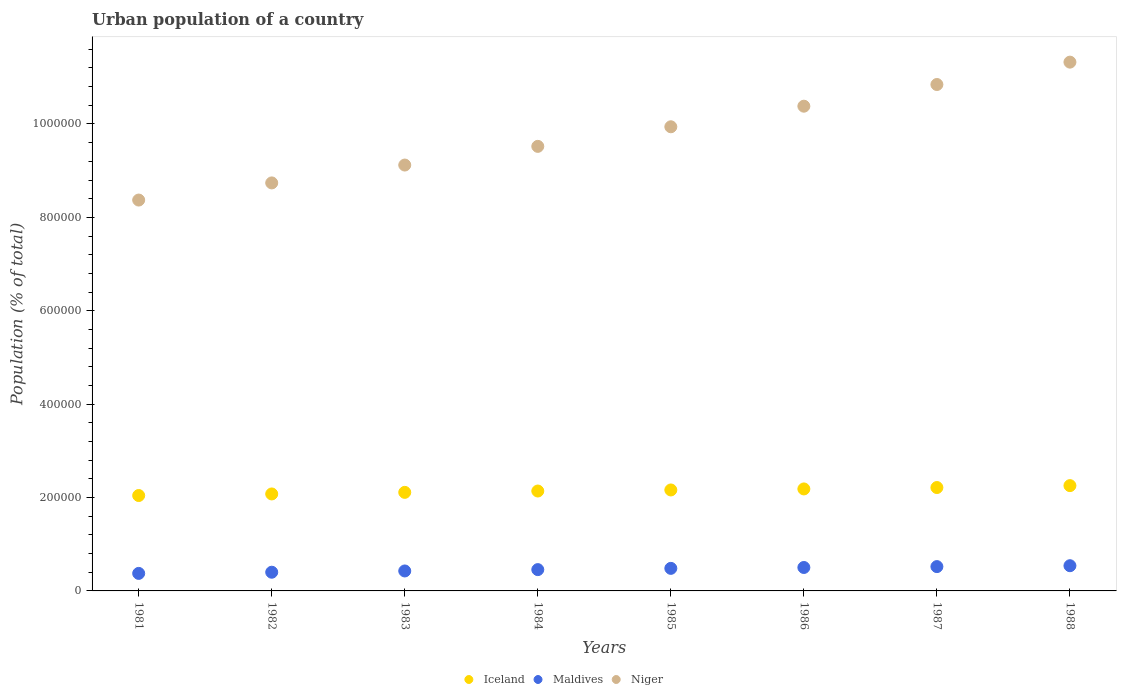Is the number of dotlines equal to the number of legend labels?
Provide a short and direct response. Yes. What is the urban population in Maldives in 1985?
Make the answer very short. 4.83e+04. Across all years, what is the maximum urban population in Niger?
Your response must be concise. 1.13e+06. Across all years, what is the minimum urban population in Niger?
Your answer should be compact. 8.37e+05. In which year was the urban population in Niger minimum?
Offer a terse response. 1981. What is the total urban population in Iceland in the graph?
Provide a short and direct response. 1.72e+06. What is the difference between the urban population in Maldives in 1981 and that in 1987?
Offer a terse response. -1.46e+04. What is the difference between the urban population in Niger in 1987 and the urban population in Maldives in 1982?
Offer a terse response. 1.04e+06. What is the average urban population in Niger per year?
Give a very brief answer. 9.78e+05. In the year 1982, what is the difference between the urban population in Iceland and urban population in Maldives?
Your answer should be compact. 1.68e+05. What is the ratio of the urban population in Maldives in 1982 to that in 1987?
Provide a succinct answer. 0.77. Is the urban population in Niger in 1981 less than that in 1982?
Provide a short and direct response. Yes. What is the difference between the highest and the second highest urban population in Niger?
Your response must be concise. 4.79e+04. What is the difference between the highest and the lowest urban population in Niger?
Provide a short and direct response. 2.95e+05. Is it the case that in every year, the sum of the urban population in Maldives and urban population in Iceland  is greater than the urban population in Niger?
Your answer should be compact. No. How many dotlines are there?
Make the answer very short. 3. Are the values on the major ticks of Y-axis written in scientific E-notation?
Your answer should be compact. No. Where does the legend appear in the graph?
Provide a short and direct response. Bottom center. How many legend labels are there?
Provide a succinct answer. 3. What is the title of the graph?
Ensure brevity in your answer.  Urban population of a country. Does "Mozambique" appear as one of the legend labels in the graph?
Ensure brevity in your answer.  No. What is the label or title of the X-axis?
Offer a very short reply. Years. What is the label or title of the Y-axis?
Make the answer very short. Population (% of total). What is the Population (% of total) of Iceland in 1981?
Offer a very short reply. 2.04e+05. What is the Population (% of total) of Maldives in 1981?
Give a very brief answer. 3.75e+04. What is the Population (% of total) of Niger in 1981?
Your response must be concise. 8.37e+05. What is the Population (% of total) in Iceland in 1982?
Provide a short and direct response. 2.08e+05. What is the Population (% of total) of Maldives in 1982?
Offer a terse response. 4.00e+04. What is the Population (% of total) in Niger in 1982?
Provide a succinct answer. 8.74e+05. What is the Population (% of total) of Iceland in 1983?
Keep it short and to the point. 2.11e+05. What is the Population (% of total) of Maldives in 1983?
Provide a short and direct response. 4.28e+04. What is the Population (% of total) in Niger in 1983?
Your answer should be compact. 9.12e+05. What is the Population (% of total) in Iceland in 1984?
Give a very brief answer. 2.14e+05. What is the Population (% of total) in Maldives in 1984?
Your response must be concise. 4.56e+04. What is the Population (% of total) in Niger in 1984?
Make the answer very short. 9.52e+05. What is the Population (% of total) in Iceland in 1985?
Your response must be concise. 2.16e+05. What is the Population (% of total) in Maldives in 1985?
Provide a succinct answer. 4.83e+04. What is the Population (% of total) of Niger in 1985?
Provide a short and direct response. 9.94e+05. What is the Population (% of total) in Iceland in 1986?
Give a very brief answer. 2.18e+05. What is the Population (% of total) in Maldives in 1986?
Give a very brief answer. 5.02e+04. What is the Population (% of total) in Niger in 1986?
Provide a succinct answer. 1.04e+06. What is the Population (% of total) in Iceland in 1987?
Your response must be concise. 2.21e+05. What is the Population (% of total) of Maldives in 1987?
Your answer should be compact. 5.21e+04. What is the Population (% of total) in Niger in 1987?
Provide a short and direct response. 1.08e+06. What is the Population (% of total) of Iceland in 1988?
Keep it short and to the point. 2.26e+05. What is the Population (% of total) in Maldives in 1988?
Provide a short and direct response. 5.40e+04. What is the Population (% of total) of Niger in 1988?
Provide a short and direct response. 1.13e+06. Across all years, what is the maximum Population (% of total) of Iceland?
Ensure brevity in your answer.  2.26e+05. Across all years, what is the maximum Population (% of total) in Maldives?
Provide a succinct answer. 5.40e+04. Across all years, what is the maximum Population (% of total) of Niger?
Provide a short and direct response. 1.13e+06. Across all years, what is the minimum Population (% of total) of Iceland?
Provide a succinct answer. 2.04e+05. Across all years, what is the minimum Population (% of total) in Maldives?
Provide a short and direct response. 3.75e+04. Across all years, what is the minimum Population (% of total) of Niger?
Your answer should be very brief. 8.37e+05. What is the total Population (% of total) of Iceland in the graph?
Keep it short and to the point. 1.72e+06. What is the total Population (% of total) in Maldives in the graph?
Provide a succinct answer. 3.71e+05. What is the total Population (% of total) in Niger in the graph?
Make the answer very short. 7.82e+06. What is the difference between the Population (% of total) in Iceland in 1981 and that in 1982?
Your response must be concise. -3374. What is the difference between the Population (% of total) in Maldives in 1981 and that in 1982?
Your answer should be very brief. -2517. What is the difference between the Population (% of total) in Niger in 1981 and that in 1982?
Your answer should be compact. -3.67e+04. What is the difference between the Population (% of total) in Iceland in 1981 and that in 1983?
Keep it short and to the point. -6762. What is the difference between the Population (% of total) of Maldives in 1981 and that in 1983?
Give a very brief answer. -5229. What is the difference between the Population (% of total) in Niger in 1981 and that in 1983?
Keep it short and to the point. -7.50e+04. What is the difference between the Population (% of total) of Iceland in 1981 and that in 1984?
Provide a succinct answer. -9635. What is the difference between the Population (% of total) in Maldives in 1981 and that in 1984?
Provide a succinct answer. -8106. What is the difference between the Population (% of total) of Niger in 1981 and that in 1984?
Your answer should be very brief. -1.15e+05. What is the difference between the Population (% of total) in Iceland in 1981 and that in 1985?
Your answer should be very brief. -1.19e+04. What is the difference between the Population (% of total) in Maldives in 1981 and that in 1985?
Offer a terse response. -1.08e+04. What is the difference between the Population (% of total) of Niger in 1981 and that in 1985?
Provide a succinct answer. -1.57e+05. What is the difference between the Population (% of total) of Iceland in 1981 and that in 1986?
Give a very brief answer. -1.41e+04. What is the difference between the Population (% of total) in Maldives in 1981 and that in 1986?
Your answer should be very brief. -1.27e+04. What is the difference between the Population (% of total) in Niger in 1981 and that in 1986?
Provide a succinct answer. -2.01e+05. What is the difference between the Population (% of total) in Iceland in 1981 and that in 1987?
Ensure brevity in your answer.  -1.71e+04. What is the difference between the Population (% of total) of Maldives in 1981 and that in 1987?
Your answer should be very brief. -1.46e+04. What is the difference between the Population (% of total) of Niger in 1981 and that in 1987?
Give a very brief answer. -2.47e+05. What is the difference between the Population (% of total) in Iceland in 1981 and that in 1988?
Make the answer very short. -2.12e+04. What is the difference between the Population (% of total) in Maldives in 1981 and that in 1988?
Provide a short and direct response. -1.65e+04. What is the difference between the Population (% of total) in Niger in 1981 and that in 1988?
Provide a succinct answer. -2.95e+05. What is the difference between the Population (% of total) of Iceland in 1982 and that in 1983?
Your answer should be compact. -3388. What is the difference between the Population (% of total) in Maldives in 1982 and that in 1983?
Keep it short and to the point. -2712. What is the difference between the Population (% of total) in Niger in 1982 and that in 1983?
Offer a very short reply. -3.83e+04. What is the difference between the Population (% of total) in Iceland in 1982 and that in 1984?
Provide a succinct answer. -6261. What is the difference between the Population (% of total) of Maldives in 1982 and that in 1984?
Provide a succinct answer. -5589. What is the difference between the Population (% of total) in Niger in 1982 and that in 1984?
Your answer should be very brief. -7.83e+04. What is the difference between the Population (% of total) of Iceland in 1982 and that in 1985?
Provide a short and direct response. -8558. What is the difference between the Population (% of total) in Maldives in 1982 and that in 1985?
Make the answer very short. -8275. What is the difference between the Population (% of total) in Niger in 1982 and that in 1985?
Your answer should be very brief. -1.20e+05. What is the difference between the Population (% of total) of Iceland in 1982 and that in 1986?
Give a very brief answer. -1.07e+04. What is the difference between the Population (% of total) in Maldives in 1982 and that in 1986?
Your answer should be compact. -1.01e+04. What is the difference between the Population (% of total) of Niger in 1982 and that in 1986?
Provide a short and direct response. -1.64e+05. What is the difference between the Population (% of total) in Iceland in 1982 and that in 1987?
Keep it short and to the point. -1.37e+04. What is the difference between the Population (% of total) of Maldives in 1982 and that in 1987?
Ensure brevity in your answer.  -1.20e+04. What is the difference between the Population (% of total) of Niger in 1982 and that in 1987?
Offer a very short reply. -2.11e+05. What is the difference between the Population (% of total) in Iceland in 1982 and that in 1988?
Your answer should be very brief. -1.78e+04. What is the difference between the Population (% of total) of Maldives in 1982 and that in 1988?
Your response must be concise. -1.39e+04. What is the difference between the Population (% of total) in Niger in 1982 and that in 1988?
Your answer should be compact. -2.59e+05. What is the difference between the Population (% of total) of Iceland in 1983 and that in 1984?
Your response must be concise. -2873. What is the difference between the Population (% of total) in Maldives in 1983 and that in 1984?
Your answer should be compact. -2877. What is the difference between the Population (% of total) of Niger in 1983 and that in 1984?
Offer a very short reply. -4.00e+04. What is the difference between the Population (% of total) of Iceland in 1983 and that in 1985?
Give a very brief answer. -5170. What is the difference between the Population (% of total) in Maldives in 1983 and that in 1985?
Keep it short and to the point. -5563. What is the difference between the Population (% of total) in Niger in 1983 and that in 1985?
Your answer should be compact. -8.20e+04. What is the difference between the Population (% of total) of Iceland in 1983 and that in 1986?
Provide a short and direct response. -7359. What is the difference between the Population (% of total) in Maldives in 1983 and that in 1986?
Your answer should be very brief. -7435. What is the difference between the Population (% of total) in Niger in 1983 and that in 1986?
Your response must be concise. -1.26e+05. What is the difference between the Population (% of total) of Iceland in 1983 and that in 1987?
Offer a very short reply. -1.04e+04. What is the difference between the Population (% of total) of Maldives in 1983 and that in 1987?
Provide a short and direct response. -9326. What is the difference between the Population (% of total) in Niger in 1983 and that in 1987?
Offer a terse response. -1.72e+05. What is the difference between the Population (% of total) of Iceland in 1983 and that in 1988?
Keep it short and to the point. -1.44e+04. What is the difference between the Population (% of total) of Maldives in 1983 and that in 1988?
Provide a short and direct response. -1.12e+04. What is the difference between the Population (% of total) in Niger in 1983 and that in 1988?
Your answer should be compact. -2.20e+05. What is the difference between the Population (% of total) of Iceland in 1984 and that in 1985?
Ensure brevity in your answer.  -2297. What is the difference between the Population (% of total) in Maldives in 1984 and that in 1985?
Keep it short and to the point. -2686. What is the difference between the Population (% of total) in Niger in 1984 and that in 1985?
Make the answer very short. -4.19e+04. What is the difference between the Population (% of total) in Iceland in 1984 and that in 1986?
Give a very brief answer. -4486. What is the difference between the Population (% of total) in Maldives in 1984 and that in 1986?
Provide a short and direct response. -4558. What is the difference between the Population (% of total) of Niger in 1984 and that in 1986?
Keep it short and to the point. -8.60e+04. What is the difference between the Population (% of total) of Iceland in 1984 and that in 1987?
Give a very brief answer. -7484. What is the difference between the Population (% of total) of Maldives in 1984 and that in 1987?
Your response must be concise. -6449. What is the difference between the Population (% of total) in Niger in 1984 and that in 1987?
Your answer should be very brief. -1.32e+05. What is the difference between the Population (% of total) of Iceland in 1984 and that in 1988?
Your answer should be very brief. -1.16e+04. What is the difference between the Population (% of total) in Maldives in 1984 and that in 1988?
Your answer should be very brief. -8351. What is the difference between the Population (% of total) in Niger in 1984 and that in 1988?
Offer a very short reply. -1.80e+05. What is the difference between the Population (% of total) of Iceland in 1985 and that in 1986?
Keep it short and to the point. -2189. What is the difference between the Population (% of total) in Maldives in 1985 and that in 1986?
Your answer should be very brief. -1872. What is the difference between the Population (% of total) of Niger in 1985 and that in 1986?
Your response must be concise. -4.41e+04. What is the difference between the Population (% of total) in Iceland in 1985 and that in 1987?
Offer a very short reply. -5187. What is the difference between the Population (% of total) in Maldives in 1985 and that in 1987?
Your answer should be very brief. -3763. What is the difference between the Population (% of total) of Niger in 1985 and that in 1987?
Make the answer very short. -9.05e+04. What is the difference between the Population (% of total) in Iceland in 1985 and that in 1988?
Give a very brief answer. -9274. What is the difference between the Population (% of total) of Maldives in 1985 and that in 1988?
Offer a very short reply. -5665. What is the difference between the Population (% of total) in Niger in 1985 and that in 1988?
Ensure brevity in your answer.  -1.38e+05. What is the difference between the Population (% of total) of Iceland in 1986 and that in 1987?
Your answer should be compact. -2998. What is the difference between the Population (% of total) in Maldives in 1986 and that in 1987?
Your answer should be compact. -1891. What is the difference between the Population (% of total) of Niger in 1986 and that in 1987?
Keep it short and to the point. -4.64e+04. What is the difference between the Population (% of total) of Iceland in 1986 and that in 1988?
Offer a terse response. -7085. What is the difference between the Population (% of total) of Maldives in 1986 and that in 1988?
Your response must be concise. -3793. What is the difference between the Population (% of total) of Niger in 1986 and that in 1988?
Keep it short and to the point. -9.43e+04. What is the difference between the Population (% of total) of Iceland in 1987 and that in 1988?
Keep it short and to the point. -4087. What is the difference between the Population (% of total) in Maldives in 1987 and that in 1988?
Ensure brevity in your answer.  -1902. What is the difference between the Population (% of total) in Niger in 1987 and that in 1988?
Provide a short and direct response. -4.79e+04. What is the difference between the Population (% of total) in Iceland in 1981 and the Population (% of total) in Maldives in 1982?
Offer a very short reply. 1.64e+05. What is the difference between the Population (% of total) of Iceland in 1981 and the Population (% of total) of Niger in 1982?
Ensure brevity in your answer.  -6.69e+05. What is the difference between the Population (% of total) in Maldives in 1981 and the Population (% of total) in Niger in 1982?
Offer a very short reply. -8.36e+05. What is the difference between the Population (% of total) in Iceland in 1981 and the Population (% of total) in Maldives in 1983?
Provide a succinct answer. 1.62e+05. What is the difference between the Population (% of total) of Iceland in 1981 and the Population (% of total) of Niger in 1983?
Make the answer very short. -7.08e+05. What is the difference between the Population (% of total) in Maldives in 1981 and the Population (% of total) in Niger in 1983?
Your answer should be compact. -8.75e+05. What is the difference between the Population (% of total) in Iceland in 1981 and the Population (% of total) in Maldives in 1984?
Keep it short and to the point. 1.59e+05. What is the difference between the Population (% of total) in Iceland in 1981 and the Population (% of total) in Niger in 1984?
Your answer should be very brief. -7.48e+05. What is the difference between the Population (% of total) in Maldives in 1981 and the Population (% of total) in Niger in 1984?
Offer a terse response. -9.15e+05. What is the difference between the Population (% of total) in Iceland in 1981 and the Population (% of total) in Maldives in 1985?
Keep it short and to the point. 1.56e+05. What is the difference between the Population (% of total) of Iceland in 1981 and the Population (% of total) of Niger in 1985?
Ensure brevity in your answer.  -7.90e+05. What is the difference between the Population (% of total) of Maldives in 1981 and the Population (% of total) of Niger in 1985?
Offer a terse response. -9.56e+05. What is the difference between the Population (% of total) of Iceland in 1981 and the Population (% of total) of Maldives in 1986?
Provide a short and direct response. 1.54e+05. What is the difference between the Population (% of total) of Iceland in 1981 and the Population (% of total) of Niger in 1986?
Offer a terse response. -8.34e+05. What is the difference between the Population (% of total) in Maldives in 1981 and the Population (% of total) in Niger in 1986?
Make the answer very short. -1.00e+06. What is the difference between the Population (% of total) in Iceland in 1981 and the Population (% of total) in Maldives in 1987?
Your answer should be very brief. 1.52e+05. What is the difference between the Population (% of total) of Iceland in 1981 and the Population (% of total) of Niger in 1987?
Your answer should be compact. -8.80e+05. What is the difference between the Population (% of total) of Maldives in 1981 and the Population (% of total) of Niger in 1987?
Give a very brief answer. -1.05e+06. What is the difference between the Population (% of total) in Iceland in 1981 and the Population (% of total) in Maldives in 1988?
Your answer should be compact. 1.50e+05. What is the difference between the Population (% of total) of Iceland in 1981 and the Population (% of total) of Niger in 1988?
Keep it short and to the point. -9.28e+05. What is the difference between the Population (% of total) in Maldives in 1981 and the Population (% of total) in Niger in 1988?
Ensure brevity in your answer.  -1.09e+06. What is the difference between the Population (% of total) of Iceland in 1982 and the Population (% of total) of Maldives in 1983?
Your answer should be compact. 1.65e+05. What is the difference between the Population (% of total) of Iceland in 1982 and the Population (% of total) of Niger in 1983?
Ensure brevity in your answer.  -7.04e+05. What is the difference between the Population (% of total) in Maldives in 1982 and the Population (% of total) in Niger in 1983?
Keep it short and to the point. -8.72e+05. What is the difference between the Population (% of total) in Iceland in 1982 and the Population (% of total) in Maldives in 1984?
Provide a short and direct response. 1.62e+05. What is the difference between the Population (% of total) of Iceland in 1982 and the Population (% of total) of Niger in 1984?
Provide a short and direct response. -7.44e+05. What is the difference between the Population (% of total) in Maldives in 1982 and the Population (% of total) in Niger in 1984?
Your answer should be compact. -9.12e+05. What is the difference between the Population (% of total) in Iceland in 1982 and the Population (% of total) in Maldives in 1985?
Provide a short and direct response. 1.59e+05. What is the difference between the Population (% of total) of Iceland in 1982 and the Population (% of total) of Niger in 1985?
Provide a short and direct response. -7.86e+05. What is the difference between the Population (% of total) of Maldives in 1982 and the Population (% of total) of Niger in 1985?
Offer a terse response. -9.54e+05. What is the difference between the Population (% of total) of Iceland in 1982 and the Population (% of total) of Maldives in 1986?
Your answer should be very brief. 1.57e+05. What is the difference between the Population (% of total) of Iceland in 1982 and the Population (% of total) of Niger in 1986?
Your response must be concise. -8.30e+05. What is the difference between the Population (% of total) in Maldives in 1982 and the Population (% of total) in Niger in 1986?
Give a very brief answer. -9.98e+05. What is the difference between the Population (% of total) of Iceland in 1982 and the Population (% of total) of Maldives in 1987?
Your answer should be compact. 1.56e+05. What is the difference between the Population (% of total) in Iceland in 1982 and the Population (% of total) in Niger in 1987?
Your response must be concise. -8.77e+05. What is the difference between the Population (% of total) in Maldives in 1982 and the Population (% of total) in Niger in 1987?
Your answer should be compact. -1.04e+06. What is the difference between the Population (% of total) of Iceland in 1982 and the Population (% of total) of Maldives in 1988?
Make the answer very short. 1.54e+05. What is the difference between the Population (% of total) of Iceland in 1982 and the Population (% of total) of Niger in 1988?
Keep it short and to the point. -9.25e+05. What is the difference between the Population (% of total) of Maldives in 1982 and the Population (% of total) of Niger in 1988?
Give a very brief answer. -1.09e+06. What is the difference between the Population (% of total) in Iceland in 1983 and the Population (% of total) in Maldives in 1984?
Offer a very short reply. 1.65e+05. What is the difference between the Population (% of total) in Iceland in 1983 and the Population (% of total) in Niger in 1984?
Provide a succinct answer. -7.41e+05. What is the difference between the Population (% of total) in Maldives in 1983 and the Population (% of total) in Niger in 1984?
Make the answer very short. -9.09e+05. What is the difference between the Population (% of total) of Iceland in 1983 and the Population (% of total) of Maldives in 1985?
Your answer should be compact. 1.63e+05. What is the difference between the Population (% of total) of Iceland in 1983 and the Population (% of total) of Niger in 1985?
Keep it short and to the point. -7.83e+05. What is the difference between the Population (% of total) in Maldives in 1983 and the Population (% of total) in Niger in 1985?
Your answer should be compact. -9.51e+05. What is the difference between the Population (% of total) of Iceland in 1983 and the Population (% of total) of Maldives in 1986?
Your response must be concise. 1.61e+05. What is the difference between the Population (% of total) of Iceland in 1983 and the Population (% of total) of Niger in 1986?
Ensure brevity in your answer.  -8.27e+05. What is the difference between the Population (% of total) in Maldives in 1983 and the Population (% of total) in Niger in 1986?
Offer a terse response. -9.95e+05. What is the difference between the Population (% of total) of Iceland in 1983 and the Population (% of total) of Maldives in 1987?
Make the answer very short. 1.59e+05. What is the difference between the Population (% of total) in Iceland in 1983 and the Population (% of total) in Niger in 1987?
Keep it short and to the point. -8.73e+05. What is the difference between the Population (% of total) of Maldives in 1983 and the Population (% of total) of Niger in 1987?
Your answer should be very brief. -1.04e+06. What is the difference between the Population (% of total) in Iceland in 1983 and the Population (% of total) in Maldives in 1988?
Provide a succinct answer. 1.57e+05. What is the difference between the Population (% of total) in Iceland in 1983 and the Population (% of total) in Niger in 1988?
Offer a very short reply. -9.21e+05. What is the difference between the Population (% of total) of Maldives in 1983 and the Population (% of total) of Niger in 1988?
Offer a terse response. -1.09e+06. What is the difference between the Population (% of total) of Iceland in 1984 and the Population (% of total) of Maldives in 1985?
Give a very brief answer. 1.66e+05. What is the difference between the Population (% of total) of Iceland in 1984 and the Population (% of total) of Niger in 1985?
Your answer should be compact. -7.80e+05. What is the difference between the Population (% of total) of Maldives in 1984 and the Population (% of total) of Niger in 1985?
Offer a very short reply. -9.48e+05. What is the difference between the Population (% of total) of Iceland in 1984 and the Population (% of total) of Maldives in 1986?
Your response must be concise. 1.64e+05. What is the difference between the Population (% of total) in Iceland in 1984 and the Population (% of total) in Niger in 1986?
Offer a very short reply. -8.24e+05. What is the difference between the Population (% of total) in Maldives in 1984 and the Population (% of total) in Niger in 1986?
Provide a short and direct response. -9.92e+05. What is the difference between the Population (% of total) of Iceland in 1984 and the Population (% of total) of Maldives in 1987?
Your answer should be very brief. 1.62e+05. What is the difference between the Population (% of total) of Iceland in 1984 and the Population (% of total) of Niger in 1987?
Your answer should be compact. -8.71e+05. What is the difference between the Population (% of total) of Maldives in 1984 and the Population (% of total) of Niger in 1987?
Your response must be concise. -1.04e+06. What is the difference between the Population (% of total) of Iceland in 1984 and the Population (% of total) of Maldives in 1988?
Provide a short and direct response. 1.60e+05. What is the difference between the Population (% of total) of Iceland in 1984 and the Population (% of total) of Niger in 1988?
Make the answer very short. -9.19e+05. What is the difference between the Population (% of total) in Maldives in 1984 and the Population (% of total) in Niger in 1988?
Your answer should be very brief. -1.09e+06. What is the difference between the Population (% of total) in Iceland in 1985 and the Population (% of total) in Maldives in 1986?
Your answer should be compact. 1.66e+05. What is the difference between the Population (% of total) of Iceland in 1985 and the Population (% of total) of Niger in 1986?
Provide a succinct answer. -8.22e+05. What is the difference between the Population (% of total) in Maldives in 1985 and the Population (% of total) in Niger in 1986?
Ensure brevity in your answer.  -9.90e+05. What is the difference between the Population (% of total) in Iceland in 1985 and the Population (% of total) in Maldives in 1987?
Provide a short and direct response. 1.64e+05. What is the difference between the Population (% of total) in Iceland in 1985 and the Population (% of total) in Niger in 1987?
Your response must be concise. -8.68e+05. What is the difference between the Population (% of total) of Maldives in 1985 and the Population (% of total) of Niger in 1987?
Provide a short and direct response. -1.04e+06. What is the difference between the Population (% of total) in Iceland in 1985 and the Population (% of total) in Maldives in 1988?
Ensure brevity in your answer.  1.62e+05. What is the difference between the Population (% of total) of Iceland in 1985 and the Population (% of total) of Niger in 1988?
Keep it short and to the point. -9.16e+05. What is the difference between the Population (% of total) in Maldives in 1985 and the Population (% of total) in Niger in 1988?
Ensure brevity in your answer.  -1.08e+06. What is the difference between the Population (% of total) in Iceland in 1986 and the Population (% of total) in Maldives in 1987?
Keep it short and to the point. 1.66e+05. What is the difference between the Population (% of total) of Iceland in 1986 and the Population (% of total) of Niger in 1987?
Offer a very short reply. -8.66e+05. What is the difference between the Population (% of total) of Maldives in 1986 and the Population (% of total) of Niger in 1987?
Provide a succinct answer. -1.03e+06. What is the difference between the Population (% of total) of Iceland in 1986 and the Population (% of total) of Maldives in 1988?
Give a very brief answer. 1.64e+05. What is the difference between the Population (% of total) in Iceland in 1986 and the Population (% of total) in Niger in 1988?
Make the answer very short. -9.14e+05. What is the difference between the Population (% of total) of Maldives in 1986 and the Population (% of total) of Niger in 1988?
Give a very brief answer. -1.08e+06. What is the difference between the Population (% of total) in Iceland in 1987 and the Population (% of total) in Maldives in 1988?
Offer a very short reply. 1.67e+05. What is the difference between the Population (% of total) of Iceland in 1987 and the Population (% of total) of Niger in 1988?
Make the answer very short. -9.11e+05. What is the difference between the Population (% of total) in Maldives in 1987 and the Population (% of total) in Niger in 1988?
Make the answer very short. -1.08e+06. What is the average Population (% of total) of Iceland per year?
Provide a succinct answer. 2.15e+05. What is the average Population (% of total) of Maldives per year?
Your answer should be very brief. 4.63e+04. What is the average Population (% of total) in Niger per year?
Provide a short and direct response. 9.78e+05. In the year 1981, what is the difference between the Population (% of total) in Iceland and Population (% of total) in Maldives?
Offer a very short reply. 1.67e+05. In the year 1981, what is the difference between the Population (% of total) in Iceland and Population (% of total) in Niger?
Offer a terse response. -6.33e+05. In the year 1981, what is the difference between the Population (% of total) of Maldives and Population (% of total) of Niger?
Offer a terse response. -8.00e+05. In the year 1982, what is the difference between the Population (% of total) in Iceland and Population (% of total) in Maldives?
Your answer should be very brief. 1.68e+05. In the year 1982, what is the difference between the Population (% of total) of Iceland and Population (% of total) of Niger?
Keep it short and to the point. -6.66e+05. In the year 1982, what is the difference between the Population (% of total) of Maldives and Population (% of total) of Niger?
Make the answer very short. -8.34e+05. In the year 1983, what is the difference between the Population (% of total) of Iceland and Population (% of total) of Maldives?
Provide a succinct answer. 1.68e+05. In the year 1983, what is the difference between the Population (% of total) in Iceland and Population (% of total) in Niger?
Provide a short and direct response. -7.01e+05. In the year 1983, what is the difference between the Population (% of total) of Maldives and Population (% of total) of Niger?
Make the answer very short. -8.69e+05. In the year 1984, what is the difference between the Population (% of total) in Iceland and Population (% of total) in Maldives?
Make the answer very short. 1.68e+05. In the year 1984, what is the difference between the Population (% of total) in Iceland and Population (% of total) in Niger?
Provide a short and direct response. -7.38e+05. In the year 1984, what is the difference between the Population (% of total) of Maldives and Population (% of total) of Niger?
Your response must be concise. -9.06e+05. In the year 1985, what is the difference between the Population (% of total) in Iceland and Population (% of total) in Maldives?
Make the answer very short. 1.68e+05. In the year 1985, what is the difference between the Population (% of total) in Iceland and Population (% of total) in Niger?
Your answer should be compact. -7.78e+05. In the year 1985, what is the difference between the Population (% of total) in Maldives and Population (% of total) in Niger?
Provide a short and direct response. -9.46e+05. In the year 1986, what is the difference between the Population (% of total) of Iceland and Population (% of total) of Maldives?
Provide a succinct answer. 1.68e+05. In the year 1986, what is the difference between the Population (% of total) of Iceland and Population (% of total) of Niger?
Keep it short and to the point. -8.20e+05. In the year 1986, what is the difference between the Population (% of total) in Maldives and Population (% of total) in Niger?
Make the answer very short. -9.88e+05. In the year 1987, what is the difference between the Population (% of total) of Iceland and Population (% of total) of Maldives?
Keep it short and to the point. 1.69e+05. In the year 1987, what is the difference between the Population (% of total) of Iceland and Population (% of total) of Niger?
Offer a terse response. -8.63e+05. In the year 1987, what is the difference between the Population (% of total) of Maldives and Population (% of total) of Niger?
Provide a succinct answer. -1.03e+06. In the year 1988, what is the difference between the Population (% of total) in Iceland and Population (% of total) in Maldives?
Keep it short and to the point. 1.72e+05. In the year 1988, what is the difference between the Population (% of total) of Iceland and Population (% of total) of Niger?
Make the answer very short. -9.07e+05. In the year 1988, what is the difference between the Population (% of total) in Maldives and Population (% of total) in Niger?
Provide a succinct answer. -1.08e+06. What is the ratio of the Population (% of total) of Iceland in 1981 to that in 1982?
Your answer should be compact. 0.98. What is the ratio of the Population (% of total) in Maldives in 1981 to that in 1982?
Your answer should be very brief. 0.94. What is the ratio of the Population (% of total) of Niger in 1981 to that in 1982?
Provide a succinct answer. 0.96. What is the ratio of the Population (% of total) in Iceland in 1981 to that in 1983?
Give a very brief answer. 0.97. What is the ratio of the Population (% of total) in Maldives in 1981 to that in 1983?
Make the answer very short. 0.88. What is the ratio of the Population (% of total) in Niger in 1981 to that in 1983?
Keep it short and to the point. 0.92. What is the ratio of the Population (% of total) of Iceland in 1981 to that in 1984?
Make the answer very short. 0.95. What is the ratio of the Population (% of total) in Maldives in 1981 to that in 1984?
Make the answer very short. 0.82. What is the ratio of the Population (% of total) in Niger in 1981 to that in 1984?
Offer a terse response. 0.88. What is the ratio of the Population (% of total) in Iceland in 1981 to that in 1985?
Your answer should be very brief. 0.94. What is the ratio of the Population (% of total) of Maldives in 1981 to that in 1985?
Offer a terse response. 0.78. What is the ratio of the Population (% of total) of Niger in 1981 to that in 1985?
Offer a terse response. 0.84. What is the ratio of the Population (% of total) of Iceland in 1981 to that in 1986?
Your response must be concise. 0.94. What is the ratio of the Population (% of total) in Maldives in 1981 to that in 1986?
Offer a terse response. 0.75. What is the ratio of the Population (% of total) of Niger in 1981 to that in 1986?
Keep it short and to the point. 0.81. What is the ratio of the Population (% of total) of Iceland in 1981 to that in 1987?
Give a very brief answer. 0.92. What is the ratio of the Population (% of total) in Maldives in 1981 to that in 1987?
Ensure brevity in your answer.  0.72. What is the ratio of the Population (% of total) of Niger in 1981 to that in 1987?
Offer a very short reply. 0.77. What is the ratio of the Population (% of total) in Iceland in 1981 to that in 1988?
Provide a succinct answer. 0.91. What is the ratio of the Population (% of total) in Maldives in 1981 to that in 1988?
Your answer should be very brief. 0.7. What is the ratio of the Population (% of total) in Niger in 1981 to that in 1988?
Provide a succinct answer. 0.74. What is the ratio of the Population (% of total) of Iceland in 1982 to that in 1983?
Your answer should be very brief. 0.98. What is the ratio of the Population (% of total) of Maldives in 1982 to that in 1983?
Your response must be concise. 0.94. What is the ratio of the Population (% of total) in Niger in 1982 to that in 1983?
Ensure brevity in your answer.  0.96. What is the ratio of the Population (% of total) in Iceland in 1982 to that in 1984?
Give a very brief answer. 0.97. What is the ratio of the Population (% of total) in Maldives in 1982 to that in 1984?
Keep it short and to the point. 0.88. What is the ratio of the Population (% of total) of Niger in 1982 to that in 1984?
Keep it short and to the point. 0.92. What is the ratio of the Population (% of total) in Iceland in 1982 to that in 1985?
Your answer should be very brief. 0.96. What is the ratio of the Population (% of total) of Maldives in 1982 to that in 1985?
Ensure brevity in your answer.  0.83. What is the ratio of the Population (% of total) in Niger in 1982 to that in 1985?
Provide a succinct answer. 0.88. What is the ratio of the Population (% of total) in Iceland in 1982 to that in 1986?
Offer a terse response. 0.95. What is the ratio of the Population (% of total) of Maldives in 1982 to that in 1986?
Ensure brevity in your answer.  0.8. What is the ratio of the Population (% of total) in Niger in 1982 to that in 1986?
Offer a terse response. 0.84. What is the ratio of the Population (% of total) of Iceland in 1982 to that in 1987?
Your response must be concise. 0.94. What is the ratio of the Population (% of total) in Maldives in 1982 to that in 1987?
Your response must be concise. 0.77. What is the ratio of the Population (% of total) of Niger in 1982 to that in 1987?
Your answer should be very brief. 0.81. What is the ratio of the Population (% of total) in Iceland in 1982 to that in 1988?
Offer a terse response. 0.92. What is the ratio of the Population (% of total) of Maldives in 1982 to that in 1988?
Your answer should be compact. 0.74. What is the ratio of the Population (% of total) of Niger in 1982 to that in 1988?
Your answer should be very brief. 0.77. What is the ratio of the Population (% of total) of Iceland in 1983 to that in 1984?
Offer a very short reply. 0.99. What is the ratio of the Population (% of total) in Maldives in 1983 to that in 1984?
Ensure brevity in your answer.  0.94. What is the ratio of the Population (% of total) of Niger in 1983 to that in 1984?
Offer a very short reply. 0.96. What is the ratio of the Population (% of total) in Iceland in 1983 to that in 1985?
Give a very brief answer. 0.98. What is the ratio of the Population (% of total) of Maldives in 1983 to that in 1985?
Keep it short and to the point. 0.88. What is the ratio of the Population (% of total) in Niger in 1983 to that in 1985?
Give a very brief answer. 0.92. What is the ratio of the Population (% of total) in Iceland in 1983 to that in 1986?
Keep it short and to the point. 0.97. What is the ratio of the Population (% of total) in Maldives in 1983 to that in 1986?
Offer a terse response. 0.85. What is the ratio of the Population (% of total) of Niger in 1983 to that in 1986?
Your response must be concise. 0.88. What is the ratio of the Population (% of total) in Iceland in 1983 to that in 1987?
Provide a short and direct response. 0.95. What is the ratio of the Population (% of total) in Maldives in 1983 to that in 1987?
Offer a very short reply. 0.82. What is the ratio of the Population (% of total) of Niger in 1983 to that in 1987?
Ensure brevity in your answer.  0.84. What is the ratio of the Population (% of total) in Iceland in 1983 to that in 1988?
Give a very brief answer. 0.94. What is the ratio of the Population (% of total) of Maldives in 1983 to that in 1988?
Your answer should be compact. 0.79. What is the ratio of the Population (% of total) in Niger in 1983 to that in 1988?
Provide a succinct answer. 0.81. What is the ratio of the Population (% of total) in Iceland in 1984 to that in 1985?
Keep it short and to the point. 0.99. What is the ratio of the Population (% of total) of Niger in 1984 to that in 1985?
Offer a terse response. 0.96. What is the ratio of the Population (% of total) of Iceland in 1984 to that in 1986?
Keep it short and to the point. 0.98. What is the ratio of the Population (% of total) of Maldives in 1984 to that in 1986?
Provide a short and direct response. 0.91. What is the ratio of the Population (% of total) of Niger in 1984 to that in 1986?
Ensure brevity in your answer.  0.92. What is the ratio of the Population (% of total) in Iceland in 1984 to that in 1987?
Offer a terse response. 0.97. What is the ratio of the Population (% of total) in Maldives in 1984 to that in 1987?
Offer a terse response. 0.88. What is the ratio of the Population (% of total) of Niger in 1984 to that in 1987?
Make the answer very short. 0.88. What is the ratio of the Population (% of total) in Iceland in 1984 to that in 1988?
Make the answer very short. 0.95. What is the ratio of the Population (% of total) in Maldives in 1984 to that in 1988?
Ensure brevity in your answer.  0.85. What is the ratio of the Population (% of total) in Niger in 1984 to that in 1988?
Make the answer very short. 0.84. What is the ratio of the Population (% of total) of Iceland in 1985 to that in 1986?
Keep it short and to the point. 0.99. What is the ratio of the Population (% of total) of Maldives in 1985 to that in 1986?
Your answer should be very brief. 0.96. What is the ratio of the Population (% of total) in Niger in 1985 to that in 1986?
Your answer should be compact. 0.96. What is the ratio of the Population (% of total) of Iceland in 1985 to that in 1987?
Give a very brief answer. 0.98. What is the ratio of the Population (% of total) of Maldives in 1985 to that in 1987?
Offer a very short reply. 0.93. What is the ratio of the Population (% of total) in Niger in 1985 to that in 1987?
Provide a succinct answer. 0.92. What is the ratio of the Population (% of total) of Iceland in 1985 to that in 1988?
Give a very brief answer. 0.96. What is the ratio of the Population (% of total) in Maldives in 1985 to that in 1988?
Provide a short and direct response. 0.9. What is the ratio of the Population (% of total) in Niger in 1985 to that in 1988?
Offer a very short reply. 0.88. What is the ratio of the Population (% of total) of Iceland in 1986 to that in 1987?
Offer a very short reply. 0.99. What is the ratio of the Population (% of total) of Maldives in 1986 to that in 1987?
Offer a very short reply. 0.96. What is the ratio of the Population (% of total) in Niger in 1986 to that in 1987?
Keep it short and to the point. 0.96. What is the ratio of the Population (% of total) in Iceland in 1986 to that in 1988?
Provide a short and direct response. 0.97. What is the ratio of the Population (% of total) in Maldives in 1986 to that in 1988?
Provide a succinct answer. 0.93. What is the ratio of the Population (% of total) in Iceland in 1987 to that in 1988?
Give a very brief answer. 0.98. What is the ratio of the Population (% of total) in Maldives in 1987 to that in 1988?
Offer a terse response. 0.96. What is the ratio of the Population (% of total) in Niger in 1987 to that in 1988?
Your answer should be compact. 0.96. What is the difference between the highest and the second highest Population (% of total) of Iceland?
Your answer should be compact. 4087. What is the difference between the highest and the second highest Population (% of total) in Maldives?
Your answer should be very brief. 1902. What is the difference between the highest and the second highest Population (% of total) in Niger?
Provide a succinct answer. 4.79e+04. What is the difference between the highest and the lowest Population (% of total) of Iceland?
Offer a very short reply. 2.12e+04. What is the difference between the highest and the lowest Population (% of total) of Maldives?
Your answer should be very brief. 1.65e+04. What is the difference between the highest and the lowest Population (% of total) in Niger?
Keep it short and to the point. 2.95e+05. 